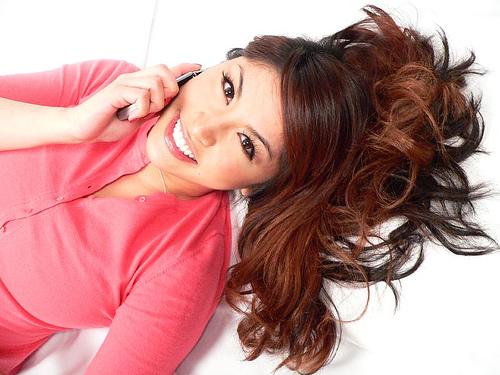Would most people consider her pose sexually suggestive?
Be succinct. No. Does she have a pixie haircut?
Answer briefly. No. Is she sad?
Write a very short answer. No. 